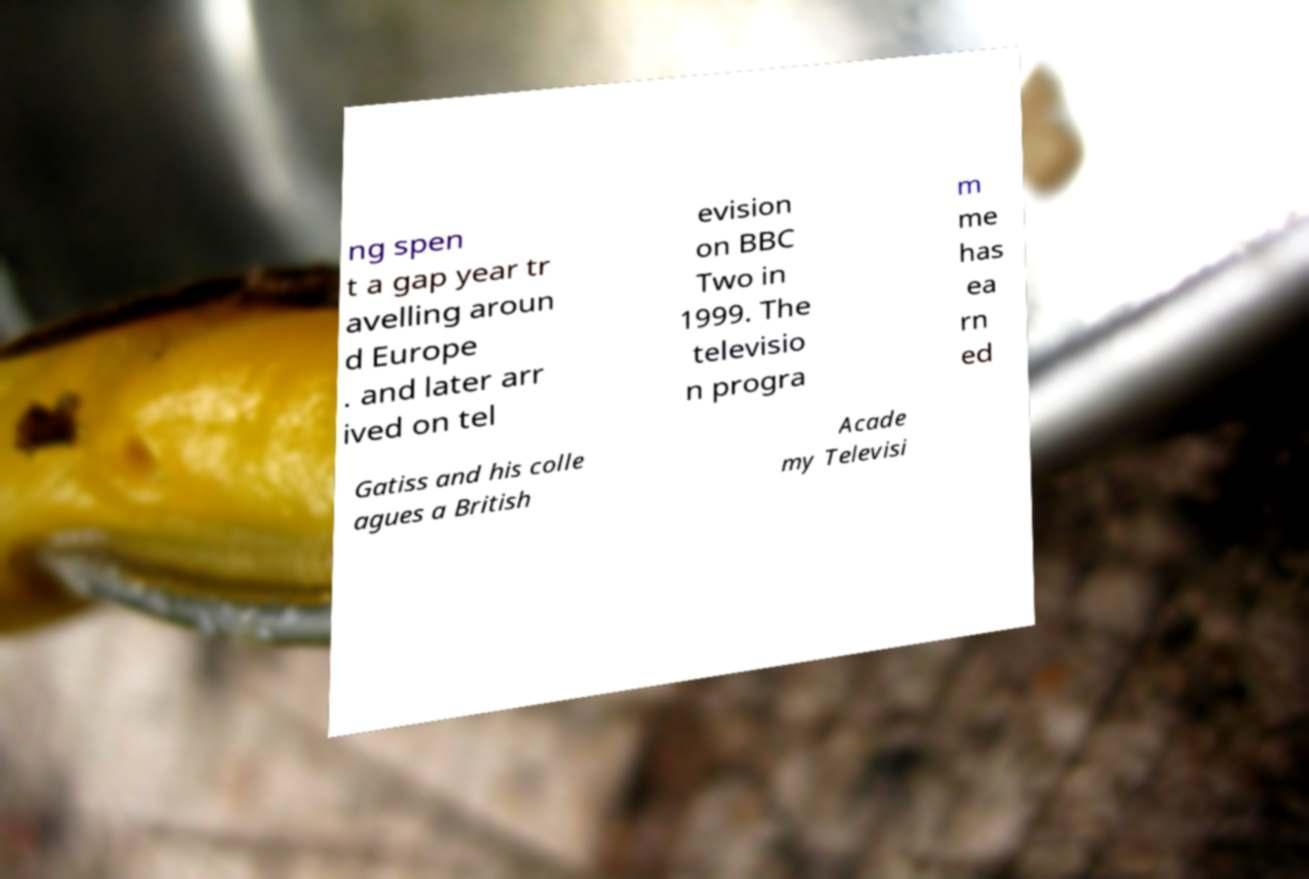Please read and relay the text visible in this image. What does it say? ng spen t a gap year tr avelling aroun d Europe . and later arr ived on tel evision on BBC Two in 1999. The televisio n progra m me has ea rn ed Gatiss and his colle agues a British Acade my Televisi 